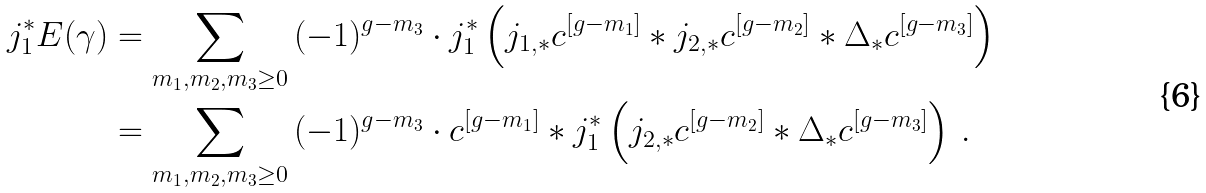<formula> <loc_0><loc_0><loc_500><loc_500>j _ { 1 } ^ { * } E ( \gamma ) & = \sum _ { m _ { 1 } , m _ { 2 } , m _ { 3 } \geq 0 } \, ( - 1 ) ^ { g - m _ { 3 } } \cdot j _ { 1 } ^ { * } \left ( j _ { 1 , * } c ^ { [ g - m _ { 1 } ] } * j _ { 2 , * } c ^ { [ g - m _ { 2 } ] } * \Delta _ { * } c ^ { [ g - m _ { 3 } ] } \right ) \\ & = \sum _ { m _ { 1 } , m _ { 2 } , m _ { 3 } \geq 0 } \, ( - 1 ) ^ { g - m _ { 3 } } \cdot c ^ { [ g - m _ { 1 } ] } * j _ { 1 } ^ { * } \left ( j _ { 2 , * } c ^ { [ g - m _ { 2 } ] } * \Delta _ { * } c ^ { [ g - m _ { 3 } ] } \right ) \, .</formula> 